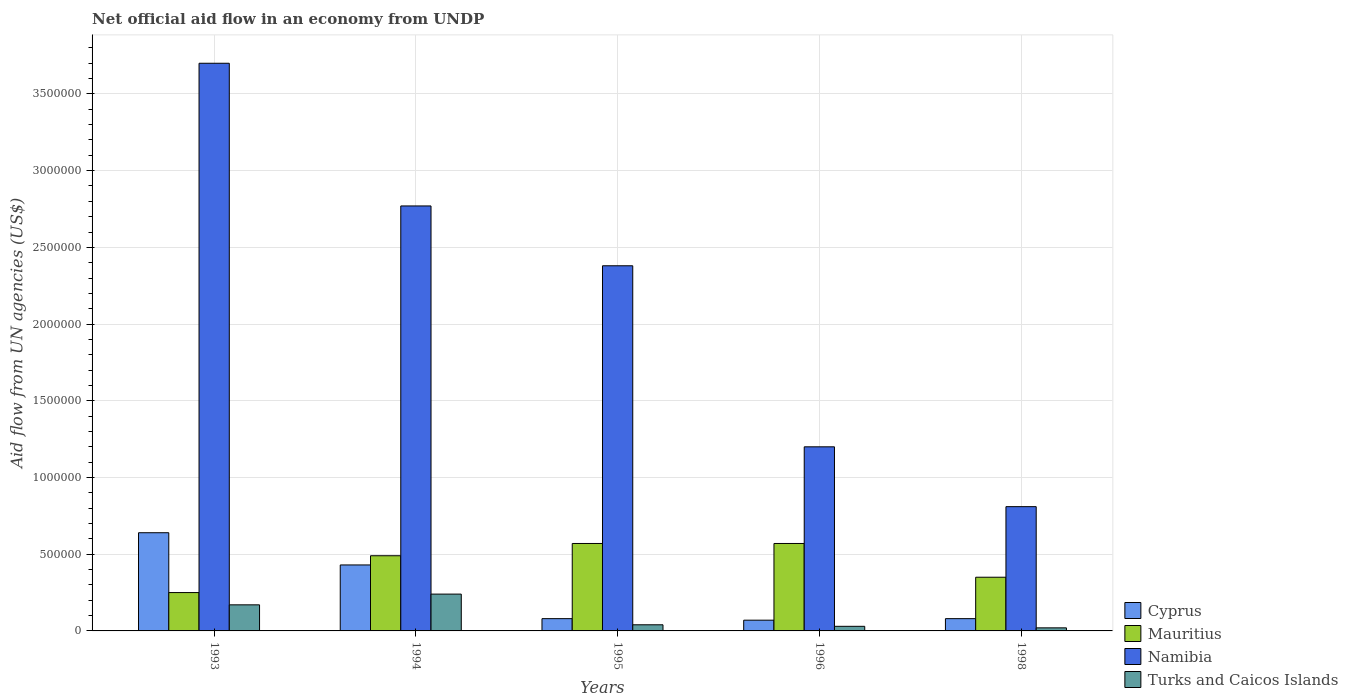How many different coloured bars are there?
Make the answer very short. 4. Are the number of bars on each tick of the X-axis equal?
Provide a short and direct response. Yes. What is the label of the 3rd group of bars from the left?
Your answer should be compact. 1995. What is the net official aid flow in Cyprus in 1996?
Your response must be concise. 7.00e+04. Across all years, what is the maximum net official aid flow in Mauritius?
Your answer should be compact. 5.70e+05. Across all years, what is the minimum net official aid flow in Mauritius?
Make the answer very short. 2.50e+05. In which year was the net official aid flow in Turks and Caicos Islands minimum?
Provide a short and direct response. 1998. What is the total net official aid flow in Namibia in the graph?
Offer a terse response. 1.09e+07. What is the difference between the net official aid flow in Mauritius in 1995 and that in 1996?
Provide a short and direct response. 0. What is the difference between the net official aid flow in Turks and Caicos Islands in 1998 and the net official aid flow in Cyprus in 1995?
Offer a very short reply. -6.00e+04. What is the average net official aid flow in Namibia per year?
Offer a terse response. 2.17e+06. In the year 1995, what is the difference between the net official aid flow in Mauritius and net official aid flow in Cyprus?
Your answer should be compact. 4.90e+05. What is the ratio of the net official aid flow in Cyprus in 1993 to that in 1994?
Give a very brief answer. 1.49. Is the net official aid flow in Cyprus in 1993 less than that in 1995?
Give a very brief answer. No. What is the difference between the highest and the second highest net official aid flow in Namibia?
Your response must be concise. 9.30e+05. What is the difference between the highest and the lowest net official aid flow in Mauritius?
Offer a terse response. 3.20e+05. In how many years, is the net official aid flow in Turks and Caicos Islands greater than the average net official aid flow in Turks and Caicos Islands taken over all years?
Provide a succinct answer. 2. Is the sum of the net official aid flow in Mauritius in 1994 and 1996 greater than the maximum net official aid flow in Namibia across all years?
Your response must be concise. No. What does the 2nd bar from the left in 1996 represents?
Your answer should be very brief. Mauritius. What does the 4th bar from the right in 1998 represents?
Ensure brevity in your answer.  Cyprus. How many bars are there?
Offer a terse response. 20. How many years are there in the graph?
Your answer should be very brief. 5. What is the difference between two consecutive major ticks on the Y-axis?
Ensure brevity in your answer.  5.00e+05. Are the values on the major ticks of Y-axis written in scientific E-notation?
Ensure brevity in your answer.  No. Does the graph contain any zero values?
Ensure brevity in your answer.  No. Where does the legend appear in the graph?
Your answer should be compact. Bottom right. What is the title of the graph?
Give a very brief answer. Net official aid flow in an economy from UNDP. What is the label or title of the X-axis?
Provide a short and direct response. Years. What is the label or title of the Y-axis?
Provide a succinct answer. Aid flow from UN agencies (US$). What is the Aid flow from UN agencies (US$) in Cyprus in 1993?
Give a very brief answer. 6.40e+05. What is the Aid flow from UN agencies (US$) in Mauritius in 1993?
Make the answer very short. 2.50e+05. What is the Aid flow from UN agencies (US$) in Namibia in 1993?
Your response must be concise. 3.70e+06. What is the Aid flow from UN agencies (US$) in Mauritius in 1994?
Make the answer very short. 4.90e+05. What is the Aid flow from UN agencies (US$) in Namibia in 1994?
Offer a very short reply. 2.77e+06. What is the Aid flow from UN agencies (US$) in Turks and Caicos Islands in 1994?
Offer a terse response. 2.40e+05. What is the Aid flow from UN agencies (US$) in Mauritius in 1995?
Ensure brevity in your answer.  5.70e+05. What is the Aid flow from UN agencies (US$) in Namibia in 1995?
Give a very brief answer. 2.38e+06. What is the Aid flow from UN agencies (US$) in Turks and Caicos Islands in 1995?
Your answer should be compact. 4.00e+04. What is the Aid flow from UN agencies (US$) in Mauritius in 1996?
Provide a succinct answer. 5.70e+05. What is the Aid flow from UN agencies (US$) in Namibia in 1996?
Provide a short and direct response. 1.20e+06. What is the Aid flow from UN agencies (US$) in Turks and Caicos Islands in 1996?
Keep it short and to the point. 3.00e+04. What is the Aid flow from UN agencies (US$) of Cyprus in 1998?
Give a very brief answer. 8.00e+04. What is the Aid flow from UN agencies (US$) in Namibia in 1998?
Your answer should be very brief. 8.10e+05. What is the Aid flow from UN agencies (US$) in Turks and Caicos Islands in 1998?
Ensure brevity in your answer.  2.00e+04. Across all years, what is the maximum Aid flow from UN agencies (US$) of Cyprus?
Provide a succinct answer. 6.40e+05. Across all years, what is the maximum Aid flow from UN agencies (US$) of Mauritius?
Provide a short and direct response. 5.70e+05. Across all years, what is the maximum Aid flow from UN agencies (US$) in Namibia?
Your response must be concise. 3.70e+06. Across all years, what is the minimum Aid flow from UN agencies (US$) in Namibia?
Your response must be concise. 8.10e+05. What is the total Aid flow from UN agencies (US$) in Cyprus in the graph?
Ensure brevity in your answer.  1.30e+06. What is the total Aid flow from UN agencies (US$) of Mauritius in the graph?
Ensure brevity in your answer.  2.23e+06. What is the total Aid flow from UN agencies (US$) in Namibia in the graph?
Your response must be concise. 1.09e+07. What is the total Aid flow from UN agencies (US$) in Turks and Caicos Islands in the graph?
Offer a very short reply. 5.00e+05. What is the difference between the Aid flow from UN agencies (US$) in Cyprus in 1993 and that in 1994?
Keep it short and to the point. 2.10e+05. What is the difference between the Aid flow from UN agencies (US$) in Namibia in 1993 and that in 1994?
Offer a terse response. 9.30e+05. What is the difference between the Aid flow from UN agencies (US$) of Turks and Caicos Islands in 1993 and that in 1994?
Your response must be concise. -7.00e+04. What is the difference between the Aid flow from UN agencies (US$) in Cyprus in 1993 and that in 1995?
Provide a succinct answer. 5.60e+05. What is the difference between the Aid flow from UN agencies (US$) in Mauritius in 1993 and that in 1995?
Offer a very short reply. -3.20e+05. What is the difference between the Aid flow from UN agencies (US$) of Namibia in 1993 and that in 1995?
Make the answer very short. 1.32e+06. What is the difference between the Aid flow from UN agencies (US$) of Turks and Caicos Islands in 1993 and that in 1995?
Provide a succinct answer. 1.30e+05. What is the difference between the Aid flow from UN agencies (US$) in Cyprus in 1993 and that in 1996?
Give a very brief answer. 5.70e+05. What is the difference between the Aid flow from UN agencies (US$) in Mauritius in 1993 and that in 1996?
Your response must be concise. -3.20e+05. What is the difference between the Aid flow from UN agencies (US$) of Namibia in 1993 and that in 1996?
Provide a succinct answer. 2.50e+06. What is the difference between the Aid flow from UN agencies (US$) in Turks and Caicos Islands in 1993 and that in 1996?
Give a very brief answer. 1.40e+05. What is the difference between the Aid flow from UN agencies (US$) of Cyprus in 1993 and that in 1998?
Offer a very short reply. 5.60e+05. What is the difference between the Aid flow from UN agencies (US$) in Mauritius in 1993 and that in 1998?
Your answer should be compact. -1.00e+05. What is the difference between the Aid flow from UN agencies (US$) of Namibia in 1993 and that in 1998?
Make the answer very short. 2.89e+06. What is the difference between the Aid flow from UN agencies (US$) in Turks and Caicos Islands in 1993 and that in 1998?
Offer a terse response. 1.50e+05. What is the difference between the Aid flow from UN agencies (US$) of Mauritius in 1994 and that in 1996?
Provide a succinct answer. -8.00e+04. What is the difference between the Aid flow from UN agencies (US$) in Namibia in 1994 and that in 1996?
Provide a short and direct response. 1.57e+06. What is the difference between the Aid flow from UN agencies (US$) in Turks and Caicos Islands in 1994 and that in 1996?
Provide a short and direct response. 2.10e+05. What is the difference between the Aid flow from UN agencies (US$) of Cyprus in 1994 and that in 1998?
Provide a short and direct response. 3.50e+05. What is the difference between the Aid flow from UN agencies (US$) in Mauritius in 1994 and that in 1998?
Keep it short and to the point. 1.40e+05. What is the difference between the Aid flow from UN agencies (US$) in Namibia in 1994 and that in 1998?
Give a very brief answer. 1.96e+06. What is the difference between the Aid flow from UN agencies (US$) in Mauritius in 1995 and that in 1996?
Ensure brevity in your answer.  0. What is the difference between the Aid flow from UN agencies (US$) of Namibia in 1995 and that in 1996?
Your answer should be very brief. 1.18e+06. What is the difference between the Aid flow from UN agencies (US$) of Namibia in 1995 and that in 1998?
Provide a short and direct response. 1.57e+06. What is the difference between the Aid flow from UN agencies (US$) of Turks and Caicos Islands in 1995 and that in 1998?
Give a very brief answer. 2.00e+04. What is the difference between the Aid flow from UN agencies (US$) in Cyprus in 1996 and that in 1998?
Ensure brevity in your answer.  -10000. What is the difference between the Aid flow from UN agencies (US$) in Mauritius in 1996 and that in 1998?
Keep it short and to the point. 2.20e+05. What is the difference between the Aid flow from UN agencies (US$) of Cyprus in 1993 and the Aid flow from UN agencies (US$) of Namibia in 1994?
Your response must be concise. -2.13e+06. What is the difference between the Aid flow from UN agencies (US$) in Cyprus in 1993 and the Aid flow from UN agencies (US$) in Turks and Caicos Islands in 1994?
Your answer should be compact. 4.00e+05. What is the difference between the Aid flow from UN agencies (US$) of Mauritius in 1993 and the Aid flow from UN agencies (US$) of Namibia in 1994?
Provide a short and direct response. -2.52e+06. What is the difference between the Aid flow from UN agencies (US$) of Namibia in 1993 and the Aid flow from UN agencies (US$) of Turks and Caicos Islands in 1994?
Your response must be concise. 3.46e+06. What is the difference between the Aid flow from UN agencies (US$) of Cyprus in 1993 and the Aid flow from UN agencies (US$) of Namibia in 1995?
Provide a succinct answer. -1.74e+06. What is the difference between the Aid flow from UN agencies (US$) of Mauritius in 1993 and the Aid flow from UN agencies (US$) of Namibia in 1995?
Provide a succinct answer. -2.13e+06. What is the difference between the Aid flow from UN agencies (US$) in Namibia in 1993 and the Aid flow from UN agencies (US$) in Turks and Caicos Islands in 1995?
Keep it short and to the point. 3.66e+06. What is the difference between the Aid flow from UN agencies (US$) in Cyprus in 1993 and the Aid flow from UN agencies (US$) in Namibia in 1996?
Your answer should be very brief. -5.60e+05. What is the difference between the Aid flow from UN agencies (US$) in Mauritius in 1993 and the Aid flow from UN agencies (US$) in Namibia in 1996?
Provide a succinct answer. -9.50e+05. What is the difference between the Aid flow from UN agencies (US$) in Namibia in 1993 and the Aid flow from UN agencies (US$) in Turks and Caicos Islands in 1996?
Keep it short and to the point. 3.67e+06. What is the difference between the Aid flow from UN agencies (US$) of Cyprus in 1993 and the Aid flow from UN agencies (US$) of Mauritius in 1998?
Offer a terse response. 2.90e+05. What is the difference between the Aid flow from UN agencies (US$) of Cyprus in 1993 and the Aid flow from UN agencies (US$) of Namibia in 1998?
Provide a short and direct response. -1.70e+05. What is the difference between the Aid flow from UN agencies (US$) of Cyprus in 1993 and the Aid flow from UN agencies (US$) of Turks and Caicos Islands in 1998?
Make the answer very short. 6.20e+05. What is the difference between the Aid flow from UN agencies (US$) in Mauritius in 1993 and the Aid flow from UN agencies (US$) in Namibia in 1998?
Provide a succinct answer. -5.60e+05. What is the difference between the Aid flow from UN agencies (US$) in Mauritius in 1993 and the Aid flow from UN agencies (US$) in Turks and Caicos Islands in 1998?
Your response must be concise. 2.30e+05. What is the difference between the Aid flow from UN agencies (US$) in Namibia in 1993 and the Aid flow from UN agencies (US$) in Turks and Caicos Islands in 1998?
Provide a short and direct response. 3.68e+06. What is the difference between the Aid flow from UN agencies (US$) in Cyprus in 1994 and the Aid flow from UN agencies (US$) in Namibia in 1995?
Keep it short and to the point. -1.95e+06. What is the difference between the Aid flow from UN agencies (US$) in Mauritius in 1994 and the Aid flow from UN agencies (US$) in Namibia in 1995?
Give a very brief answer. -1.89e+06. What is the difference between the Aid flow from UN agencies (US$) in Mauritius in 1994 and the Aid flow from UN agencies (US$) in Turks and Caicos Islands in 1995?
Offer a terse response. 4.50e+05. What is the difference between the Aid flow from UN agencies (US$) of Namibia in 1994 and the Aid flow from UN agencies (US$) of Turks and Caicos Islands in 1995?
Offer a terse response. 2.73e+06. What is the difference between the Aid flow from UN agencies (US$) of Cyprus in 1994 and the Aid flow from UN agencies (US$) of Mauritius in 1996?
Offer a terse response. -1.40e+05. What is the difference between the Aid flow from UN agencies (US$) in Cyprus in 1994 and the Aid flow from UN agencies (US$) in Namibia in 1996?
Your answer should be very brief. -7.70e+05. What is the difference between the Aid flow from UN agencies (US$) in Cyprus in 1994 and the Aid flow from UN agencies (US$) in Turks and Caicos Islands in 1996?
Keep it short and to the point. 4.00e+05. What is the difference between the Aid flow from UN agencies (US$) in Mauritius in 1994 and the Aid flow from UN agencies (US$) in Namibia in 1996?
Keep it short and to the point. -7.10e+05. What is the difference between the Aid flow from UN agencies (US$) of Mauritius in 1994 and the Aid flow from UN agencies (US$) of Turks and Caicos Islands in 1996?
Provide a succinct answer. 4.60e+05. What is the difference between the Aid flow from UN agencies (US$) of Namibia in 1994 and the Aid flow from UN agencies (US$) of Turks and Caicos Islands in 1996?
Make the answer very short. 2.74e+06. What is the difference between the Aid flow from UN agencies (US$) in Cyprus in 1994 and the Aid flow from UN agencies (US$) in Namibia in 1998?
Your answer should be compact. -3.80e+05. What is the difference between the Aid flow from UN agencies (US$) of Cyprus in 1994 and the Aid flow from UN agencies (US$) of Turks and Caicos Islands in 1998?
Your answer should be compact. 4.10e+05. What is the difference between the Aid flow from UN agencies (US$) of Mauritius in 1994 and the Aid flow from UN agencies (US$) of Namibia in 1998?
Your answer should be very brief. -3.20e+05. What is the difference between the Aid flow from UN agencies (US$) in Mauritius in 1994 and the Aid flow from UN agencies (US$) in Turks and Caicos Islands in 1998?
Provide a short and direct response. 4.70e+05. What is the difference between the Aid flow from UN agencies (US$) of Namibia in 1994 and the Aid flow from UN agencies (US$) of Turks and Caicos Islands in 1998?
Offer a very short reply. 2.75e+06. What is the difference between the Aid flow from UN agencies (US$) in Cyprus in 1995 and the Aid flow from UN agencies (US$) in Mauritius in 1996?
Keep it short and to the point. -4.90e+05. What is the difference between the Aid flow from UN agencies (US$) of Cyprus in 1995 and the Aid flow from UN agencies (US$) of Namibia in 1996?
Provide a short and direct response. -1.12e+06. What is the difference between the Aid flow from UN agencies (US$) in Mauritius in 1995 and the Aid flow from UN agencies (US$) in Namibia in 1996?
Keep it short and to the point. -6.30e+05. What is the difference between the Aid flow from UN agencies (US$) of Mauritius in 1995 and the Aid flow from UN agencies (US$) of Turks and Caicos Islands in 1996?
Provide a succinct answer. 5.40e+05. What is the difference between the Aid flow from UN agencies (US$) of Namibia in 1995 and the Aid flow from UN agencies (US$) of Turks and Caicos Islands in 1996?
Give a very brief answer. 2.35e+06. What is the difference between the Aid flow from UN agencies (US$) in Cyprus in 1995 and the Aid flow from UN agencies (US$) in Namibia in 1998?
Your answer should be very brief. -7.30e+05. What is the difference between the Aid flow from UN agencies (US$) of Cyprus in 1995 and the Aid flow from UN agencies (US$) of Turks and Caicos Islands in 1998?
Provide a short and direct response. 6.00e+04. What is the difference between the Aid flow from UN agencies (US$) of Namibia in 1995 and the Aid flow from UN agencies (US$) of Turks and Caicos Islands in 1998?
Offer a terse response. 2.36e+06. What is the difference between the Aid flow from UN agencies (US$) in Cyprus in 1996 and the Aid flow from UN agencies (US$) in Mauritius in 1998?
Offer a very short reply. -2.80e+05. What is the difference between the Aid flow from UN agencies (US$) of Cyprus in 1996 and the Aid flow from UN agencies (US$) of Namibia in 1998?
Ensure brevity in your answer.  -7.40e+05. What is the difference between the Aid flow from UN agencies (US$) in Namibia in 1996 and the Aid flow from UN agencies (US$) in Turks and Caicos Islands in 1998?
Provide a short and direct response. 1.18e+06. What is the average Aid flow from UN agencies (US$) of Mauritius per year?
Provide a short and direct response. 4.46e+05. What is the average Aid flow from UN agencies (US$) in Namibia per year?
Your answer should be compact. 2.17e+06. What is the average Aid flow from UN agencies (US$) in Turks and Caicos Islands per year?
Give a very brief answer. 1.00e+05. In the year 1993, what is the difference between the Aid flow from UN agencies (US$) in Cyprus and Aid flow from UN agencies (US$) in Mauritius?
Your answer should be compact. 3.90e+05. In the year 1993, what is the difference between the Aid flow from UN agencies (US$) in Cyprus and Aid flow from UN agencies (US$) in Namibia?
Ensure brevity in your answer.  -3.06e+06. In the year 1993, what is the difference between the Aid flow from UN agencies (US$) in Cyprus and Aid flow from UN agencies (US$) in Turks and Caicos Islands?
Your answer should be very brief. 4.70e+05. In the year 1993, what is the difference between the Aid flow from UN agencies (US$) in Mauritius and Aid flow from UN agencies (US$) in Namibia?
Make the answer very short. -3.45e+06. In the year 1993, what is the difference between the Aid flow from UN agencies (US$) of Mauritius and Aid flow from UN agencies (US$) of Turks and Caicos Islands?
Your response must be concise. 8.00e+04. In the year 1993, what is the difference between the Aid flow from UN agencies (US$) in Namibia and Aid flow from UN agencies (US$) in Turks and Caicos Islands?
Make the answer very short. 3.53e+06. In the year 1994, what is the difference between the Aid flow from UN agencies (US$) of Cyprus and Aid flow from UN agencies (US$) of Mauritius?
Provide a succinct answer. -6.00e+04. In the year 1994, what is the difference between the Aid flow from UN agencies (US$) in Cyprus and Aid flow from UN agencies (US$) in Namibia?
Offer a very short reply. -2.34e+06. In the year 1994, what is the difference between the Aid flow from UN agencies (US$) of Cyprus and Aid flow from UN agencies (US$) of Turks and Caicos Islands?
Give a very brief answer. 1.90e+05. In the year 1994, what is the difference between the Aid flow from UN agencies (US$) of Mauritius and Aid flow from UN agencies (US$) of Namibia?
Give a very brief answer. -2.28e+06. In the year 1994, what is the difference between the Aid flow from UN agencies (US$) of Mauritius and Aid flow from UN agencies (US$) of Turks and Caicos Islands?
Provide a succinct answer. 2.50e+05. In the year 1994, what is the difference between the Aid flow from UN agencies (US$) in Namibia and Aid flow from UN agencies (US$) in Turks and Caicos Islands?
Give a very brief answer. 2.53e+06. In the year 1995, what is the difference between the Aid flow from UN agencies (US$) in Cyprus and Aid flow from UN agencies (US$) in Mauritius?
Ensure brevity in your answer.  -4.90e+05. In the year 1995, what is the difference between the Aid flow from UN agencies (US$) in Cyprus and Aid flow from UN agencies (US$) in Namibia?
Your answer should be compact. -2.30e+06. In the year 1995, what is the difference between the Aid flow from UN agencies (US$) of Mauritius and Aid flow from UN agencies (US$) of Namibia?
Keep it short and to the point. -1.81e+06. In the year 1995, what is the difference between the Aid flow from UN agencies (US$) of Mauritius and Aid flow from UN agencies (US$) of Turks and Caicos Islands?
Ensure brevity in your answer.  5.30e+05. In the year 1995, what is the difference between the Aid flow from UN agencies (US$) of Namibia and Aid flow from UN agencies (US$) of Turks and Caicos Islands?
Ensure brevity in your answer.  2.34e+06. In the year 1996, what is the difference between the Aid flow from UN agencies (US$) of Cyprus and Aid flow from UN agencies (US$) of Mauritius?
Make the answer very short. -5.00e+05. In the year 1996, what is the difference between the Aid flow from UN agencies (US$) of Cyprus and Aid flow from UN agencies (US$) of Namibia?
Ensure brevity in your answer.  -1.13e+06. In the year 1996, what is the difference between the Aid flow from UN agencies (US$) in Mauritius and Aid flow from UN agencies (US$) in Namibia?
Keep it short and to the point. -6.30e+05. In the year 1996, what is the difference between the Aid flow from UN agencies (US$) in Mauritius and Aid flow from UN agencies (US$) in Turks and Caicos Islands?
Offer a terse response. 5.40e+05. In the year 1996, what is the difference between the Aid flow from UN agencies (US$) in Namibia and Aid flow from UN agencies (US$) in Turks and Caicos Islands?
Your answer should be very brief. 1.17e+06. In the year 1998, what is the difference between the Aid flow from UN agencies (US$) in Cyprus and Aid flow from UN agencies (US$) in Mauritius?
Keep it short and to the point. -2.70e+05. In the year 1998, what is the difference between the Aid flow from UN agencies (US$) in Cyprus and Aid flow from UN agencies (US$) in Namibia?
Make the answer very short. -7.30e+05. In the year 1998, what is the difference between the Aid flow from UN agencies (US$) of Cyprus and Aid flow from UN agencies (US$) of Turks and Caicos Islands?
Your response must be concise. 6.00e+04. In the year 1998, what is the difference between the Aid flow from UN agencies (US$) in Mauritius and Aid flow from UN agencies (US$) in Namibia?
Your response must be concise. -4.60e+05. In the year 1998, what is the difference between the Aid flow from UN agencies (US$) of Mauritius and Aid flow from UN agencies (US$) of Turks and Caicos Islands?
Provide a short and direct response. 3.30e+05. In the year 1998, what is the difference between the Aid flow from UN agencies (US$) of Namibia and Aid flow from UN agencies (US$) of Turks and Caicos Islands?
Your response must be concise. 7.90e+05. What is the ratio of the Aid flow from UN agencies (US$) of Cyprus in 1993 to that in 1994?
Provide a succinct answer. 1.49. What is the ratio of the Aid flow from UN agencies (US$) of Mauritius in 1993 to that in 1994?
Give a very brief answer. 0.51. What is the ratio of the Aid flow from UN agencies (US$) in Namibia in 1993 to that in 1994?
Your response must be concise. 1.34. What is the ratio of the Aid flow from UN agencies (US$) of Turks and Caicos Islands in 1993 to that in 1994?
Your response must be concise. 0.71. What is the ratio of the Aid flow from UN agencies (US$) of Cyprus in 1993 to that in 1995?
Ensure brevity in your answer.  8. What is the ratio of the Aid flow from UN agencies (US$) of Mauritius in 1993 to that in 1995?
Your answer should be compact. 0.44. What is the ratio of the Aid flow from UN agencies (US$) of Namibia in 1993 to that in 1995?
Provide a succinct answer. 1.55. What is the ratio of the Aid flow from UN agencies (US$) of Turks and Caicos Islands in 1993 to that in 1995?
Keep it short and to the point. 4.25. What is the ratio of the Aid flow from UN agencies (US$) in Cyprus in 1993 to that in 1996?
Your answer should be compact. 9.14. What is the ratio of the Aid flow from UN agencies (US$) in Mauritius in 1993 to that in 1996?
Keep it short and to the point. 0.44. What is the ratio of the Aid flow from UN agencies (US$) in Namibia in 1993 to that in 1996?
Keep it short and to the point. 3.08. What is the ratio of the Aid flow from UN agencies (US$) in Turks and Caicos Islands in 1993 to that in 1996?
Offer a very short reply. 5.67. What is the ratio of the Aid flow from UN agencies (US$) of Namibia in 1993 to that in 1998?
Provide a succinct answer. 4.57. What is the ratio of the Aid flow from UN agencies (US$) in Turks and Caicos Islands in 1993 to that in 1998?
Make the answer very short. 8.5. What is the ratio of the Aid flow from UN agencies (US$) of Cyprus in 1994 to that in 1995?
Provide a succinct answer. 5.38. What is the ratio of the Aid flow from UN agencies (US$) in Mauritius in 1994 to that in 1995?
Keep it short and to the point. 0.86. What is the ratio of the Aid flow from UN agencies (US$) in Namibia in 1994 to that in 1995?
Offer a very short reply. 1.16. What is the ratio of the Aid flow from UN agencies (US$) of Cyprus in 1994 to that in 1996?
Offer a very short reply. 6.14. What is the ratio of the Aid flow from UN agencies (US$) of Mauritius in 1994 to that in 1996?
Provide a short and direct response. 0.86. What is the ratio of the Aid flow from UN agencies (US$) of Namibia in 1994 to that in 1996?
Provide a succinct answer. 2.31. What is the ratio of the Aid flow from UN agencies (US$) of Turks and Caicos Islands in 1994 to that in 1996?
Give a very brief answer. 8. What is the ratio of the Aid flow from UN agencies (US$) of Cyprus in 1994 to that in 1998?
Offer a terse response. 5.38. What is the ratio of the Aid flow from UN agencies (US$) of Mauritius in 1994 to that in 1998?
Your response must be concise. 1.4. What is the ratio of the Aid flow from UN agencies (US$) of Namibia in 1994 to that in 1998?
Your answer should be very brief. 3.42. What is the ratio of the Aid flow from UN agencies (US$) of Turks and Caicos Islands in 1994 to that in 1998?
Give a very brief answer. 12. What is the ratio of the Aid flow from UN agencies (US$) of Namibia in 1995 to that in 1996?
Give a very brief answer. 1.98. What is the ratio of the Aid flow from UN agencies (US$) in Cyprus in 1995 to that in 1998?
Give a very brief answer. 1. What is the ratio of the Aid flow from UN agencies (US$) in Mauritius in 1995 to that in 1998?
Offer a very short reply. 1.63. What is the ratio of the Aid flow from UN agencies (US$) of Namibia in 1995 to that in 1998?
Make the answer very short. 2.94. What is the ratio of the Aid flow from UN agencies (US$) in Cyprus in 1996 to that in 1998?
Your answer should be compact. 0.88. What is the ratio of the Aid flow from UN agencies (US$) in Mauritius in 1996 to that in 1998?
Ensure brevity in your answer.  1.63. What is the ratio of the Aid flow from UN agencies (US$) in Namibia in 1996 to that in 1998?
Give a very brief answer. 1.48. What is the ratio of the Aid flow from UN agencies (US$) of Turks and Caicos Islands in 1996 to that in 1998?
Your answer should be very brief. 1.5. What is the difference between the highest and the second highest Aid flow from UN agencies (US$) in Cyprus?
Ensure brevity in your answer.  2.10e+05. What is the difference between the highest and the second highest Aid flow from UN agencies (US$) in Namibia?
Your answer should be very brief. 9.30e+05. What is the difference between the highest and the second highest Aid flow from UN agencies (US$) of Turks and Caicos Islands?
Provide a short and direct response. 7.00e+04. What is the difference between the highest and the lowest Aid flow from UN agencies (US$) in Cyprus?
Ensure brevity in your answer.  5.70e+05. What is the difference between the highest and the lowest Aid flow from UN agencies (US$) in Mauritius?
Make the answer very short. 3.20e+05. What is the difference between the highest and the lowest Aid flow from UN agencies (US$) of Namibia?
Your answer should be very brief. 2.89e+06. 